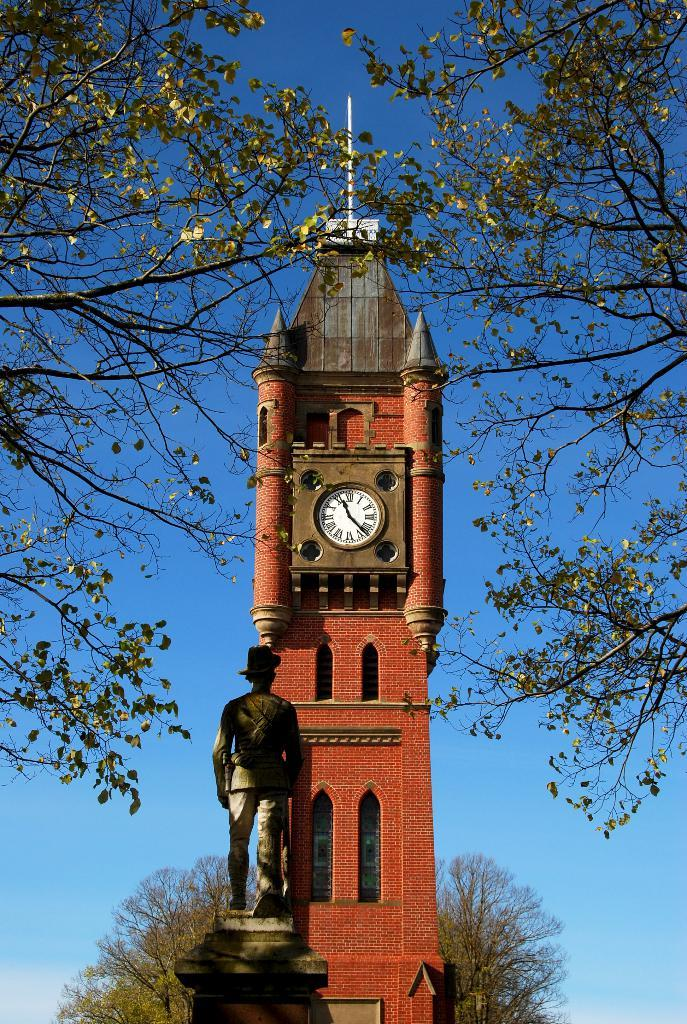<image>
Relay a brief, clear account of the picture shown. A clock tower shows that the time is a little after 11:20 in the morning. 